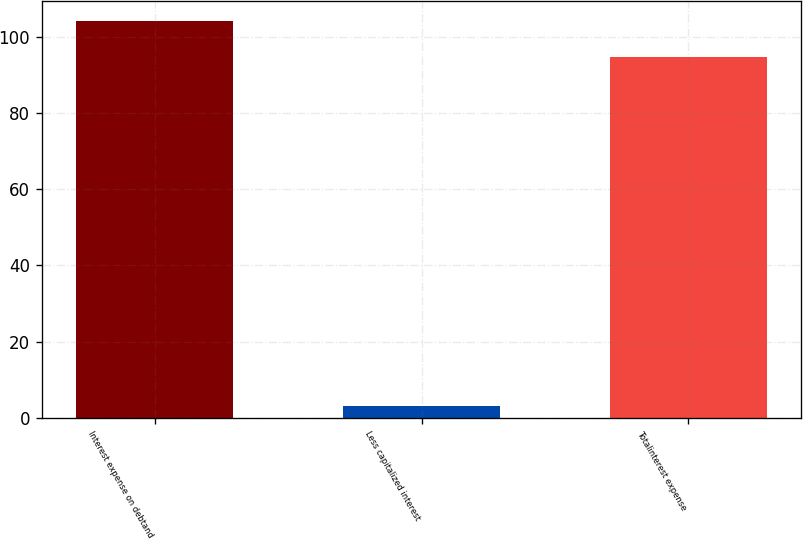Convert chart to OTSL. <chart><loc_0><loc_0><loc_500><loc_500><bar_chart><fcel>Interest expense on debtand<fcel>Less capitalized interest<fcel>Totalinterest expense<nl><fcel>104.28<fcel>3<fcel>94.8<nl></chart> 